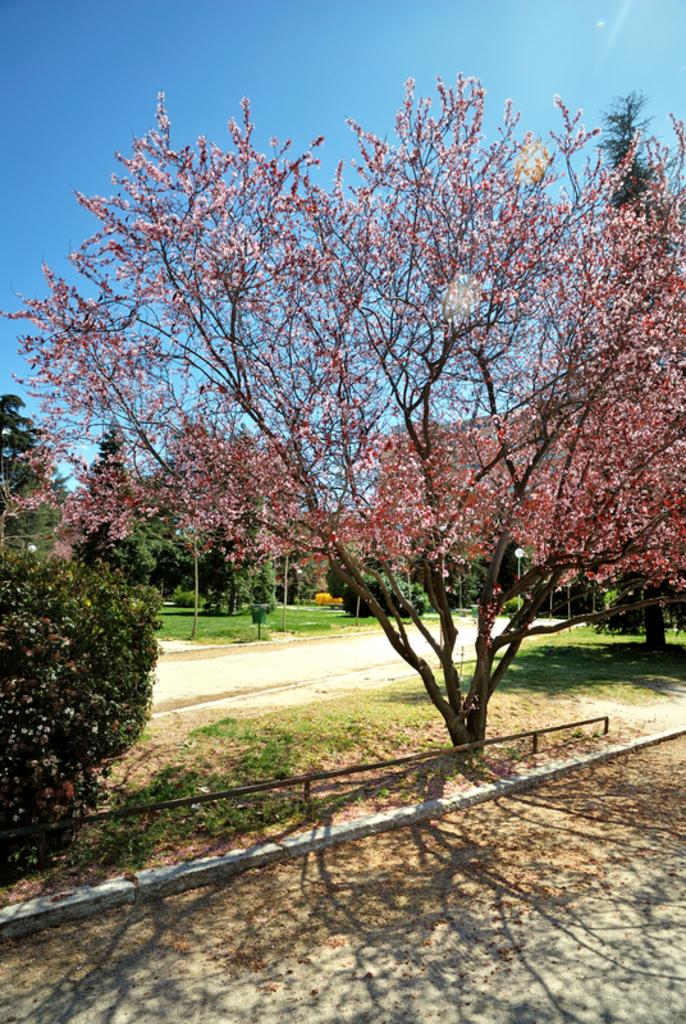What type of vegetation can be seen in the image? There are trees in the image. What else can be seen on the ground in the image? There is grass in the image. What is visible at the top of the image? The sky is visible at the top of the image. Can you tell me how many times the trees have signed an agreement in the image? There are no agreements or signatures present in the image; it features trees, grass, and the sky. Is there a skateboard visible in the image? There is no skateboard present in the image. 